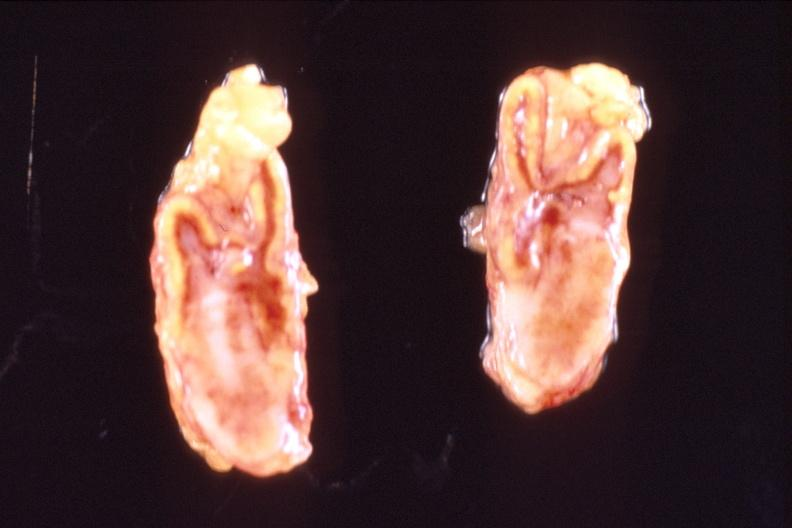what is present?
Answer the question using a single word or phrase. Endocrine 